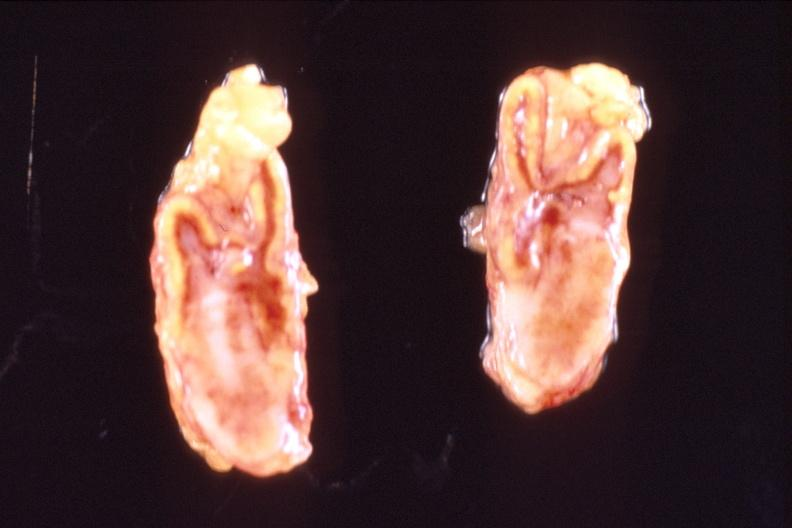what is present?
Answer the question using a single word or phrase. Endocrine 